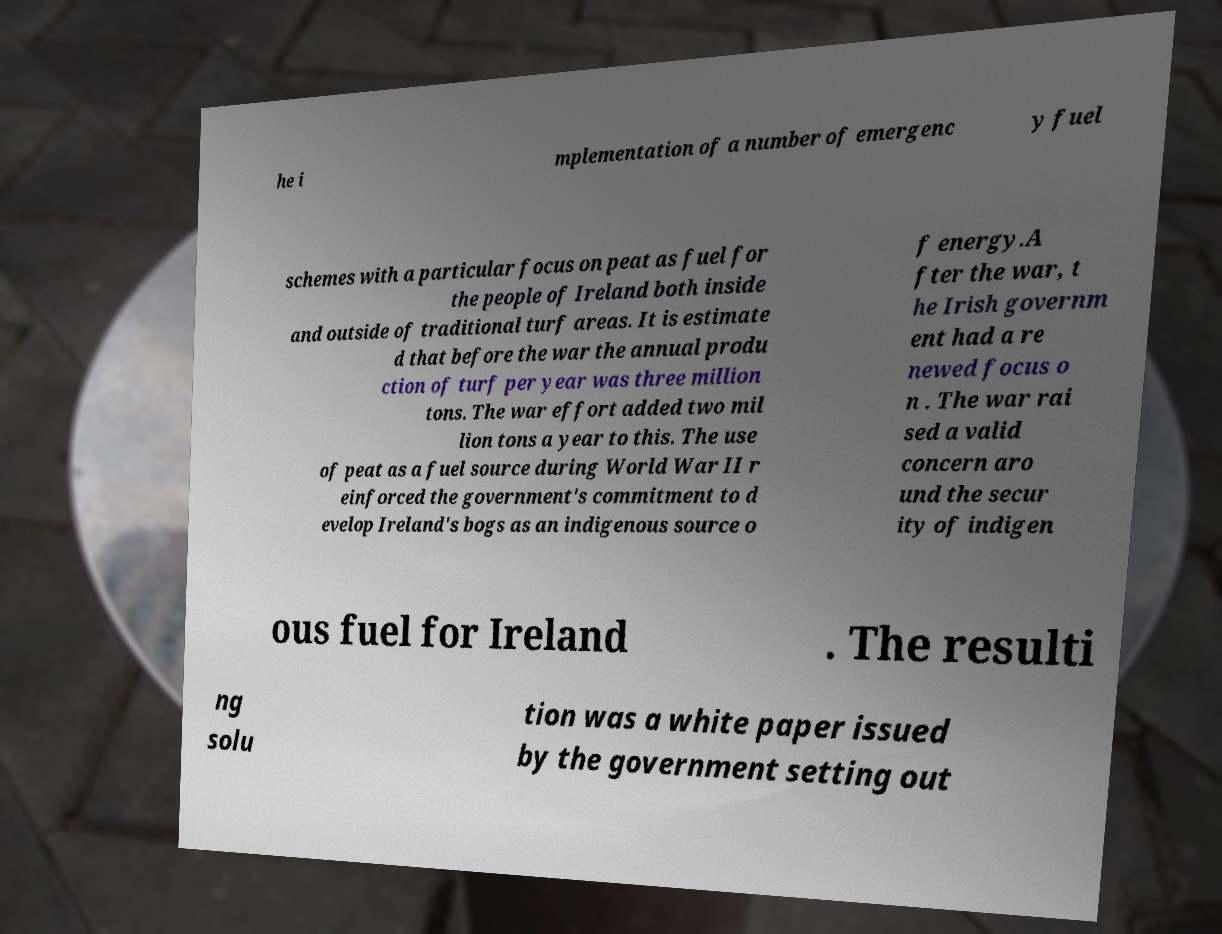Can you accurately transcribe the text from the provided image for me? he i mplementation of a number of emergenc y fuel schemes with a particular focus on peat as fuel for the people of Ireland both inside and outside of traditional turf areas. It is estimate d that before the war the annual produ ction of turf per year was three million tons. The war effort added two mil lion tons a year to this. The use of peat as a fuel source during World War II r einforced the government's commitment to d evelop Ireland's bogs as an indigenous source o f energy.A fter the war, t he Irish governm ent had a re newed focus o n . The war rai sed a valid concern aro und the secur ity of indigen ous fuel for Ireland . The resulti ng solu tion was a white paper issued by the government setting out 